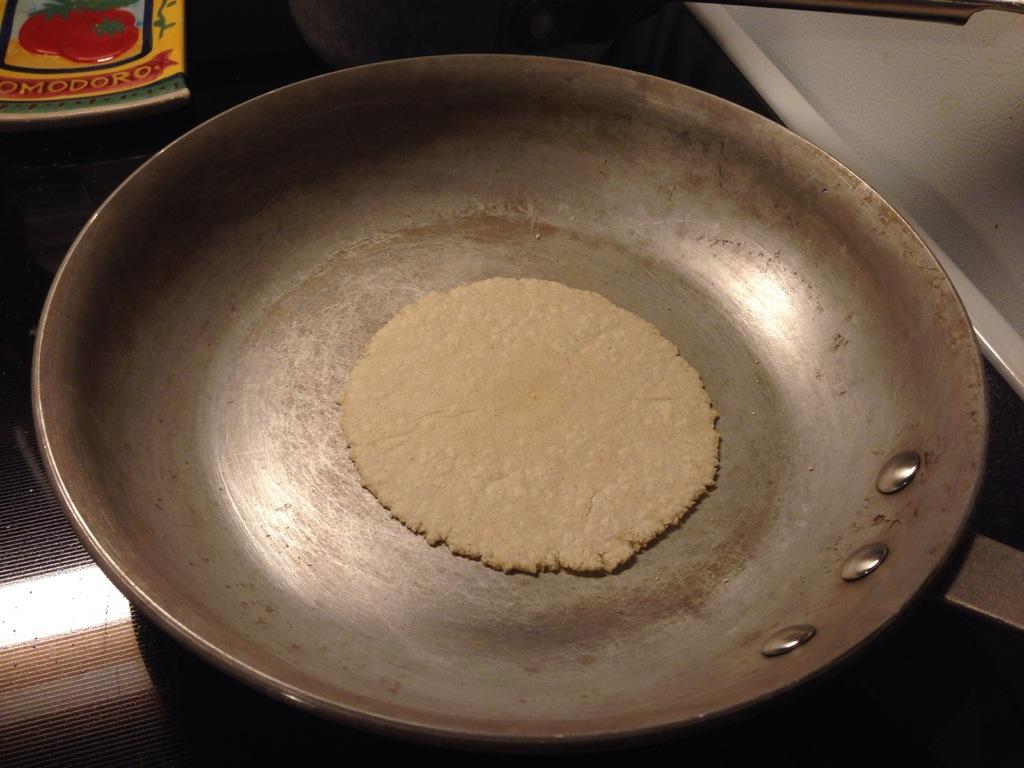What type of food can be seen in the image? There is food in the image, but the specific type cannot be determined from the provided facts. What is the pan used for in the image? The pan is likely used for cooking or serving the food in the image, but its exact purpose cannot be determined from the provided facts. What is the book about in the image? The content of the book cannot be determined from the provided facts. What is the white object in the image? The white object in the image is not described in the provided facts, so its identity cannot be determined. What type of fan is visible in the image? There is no fan present in the image. What design is featured on the canvas in the image? There is no canvas present in the image. 